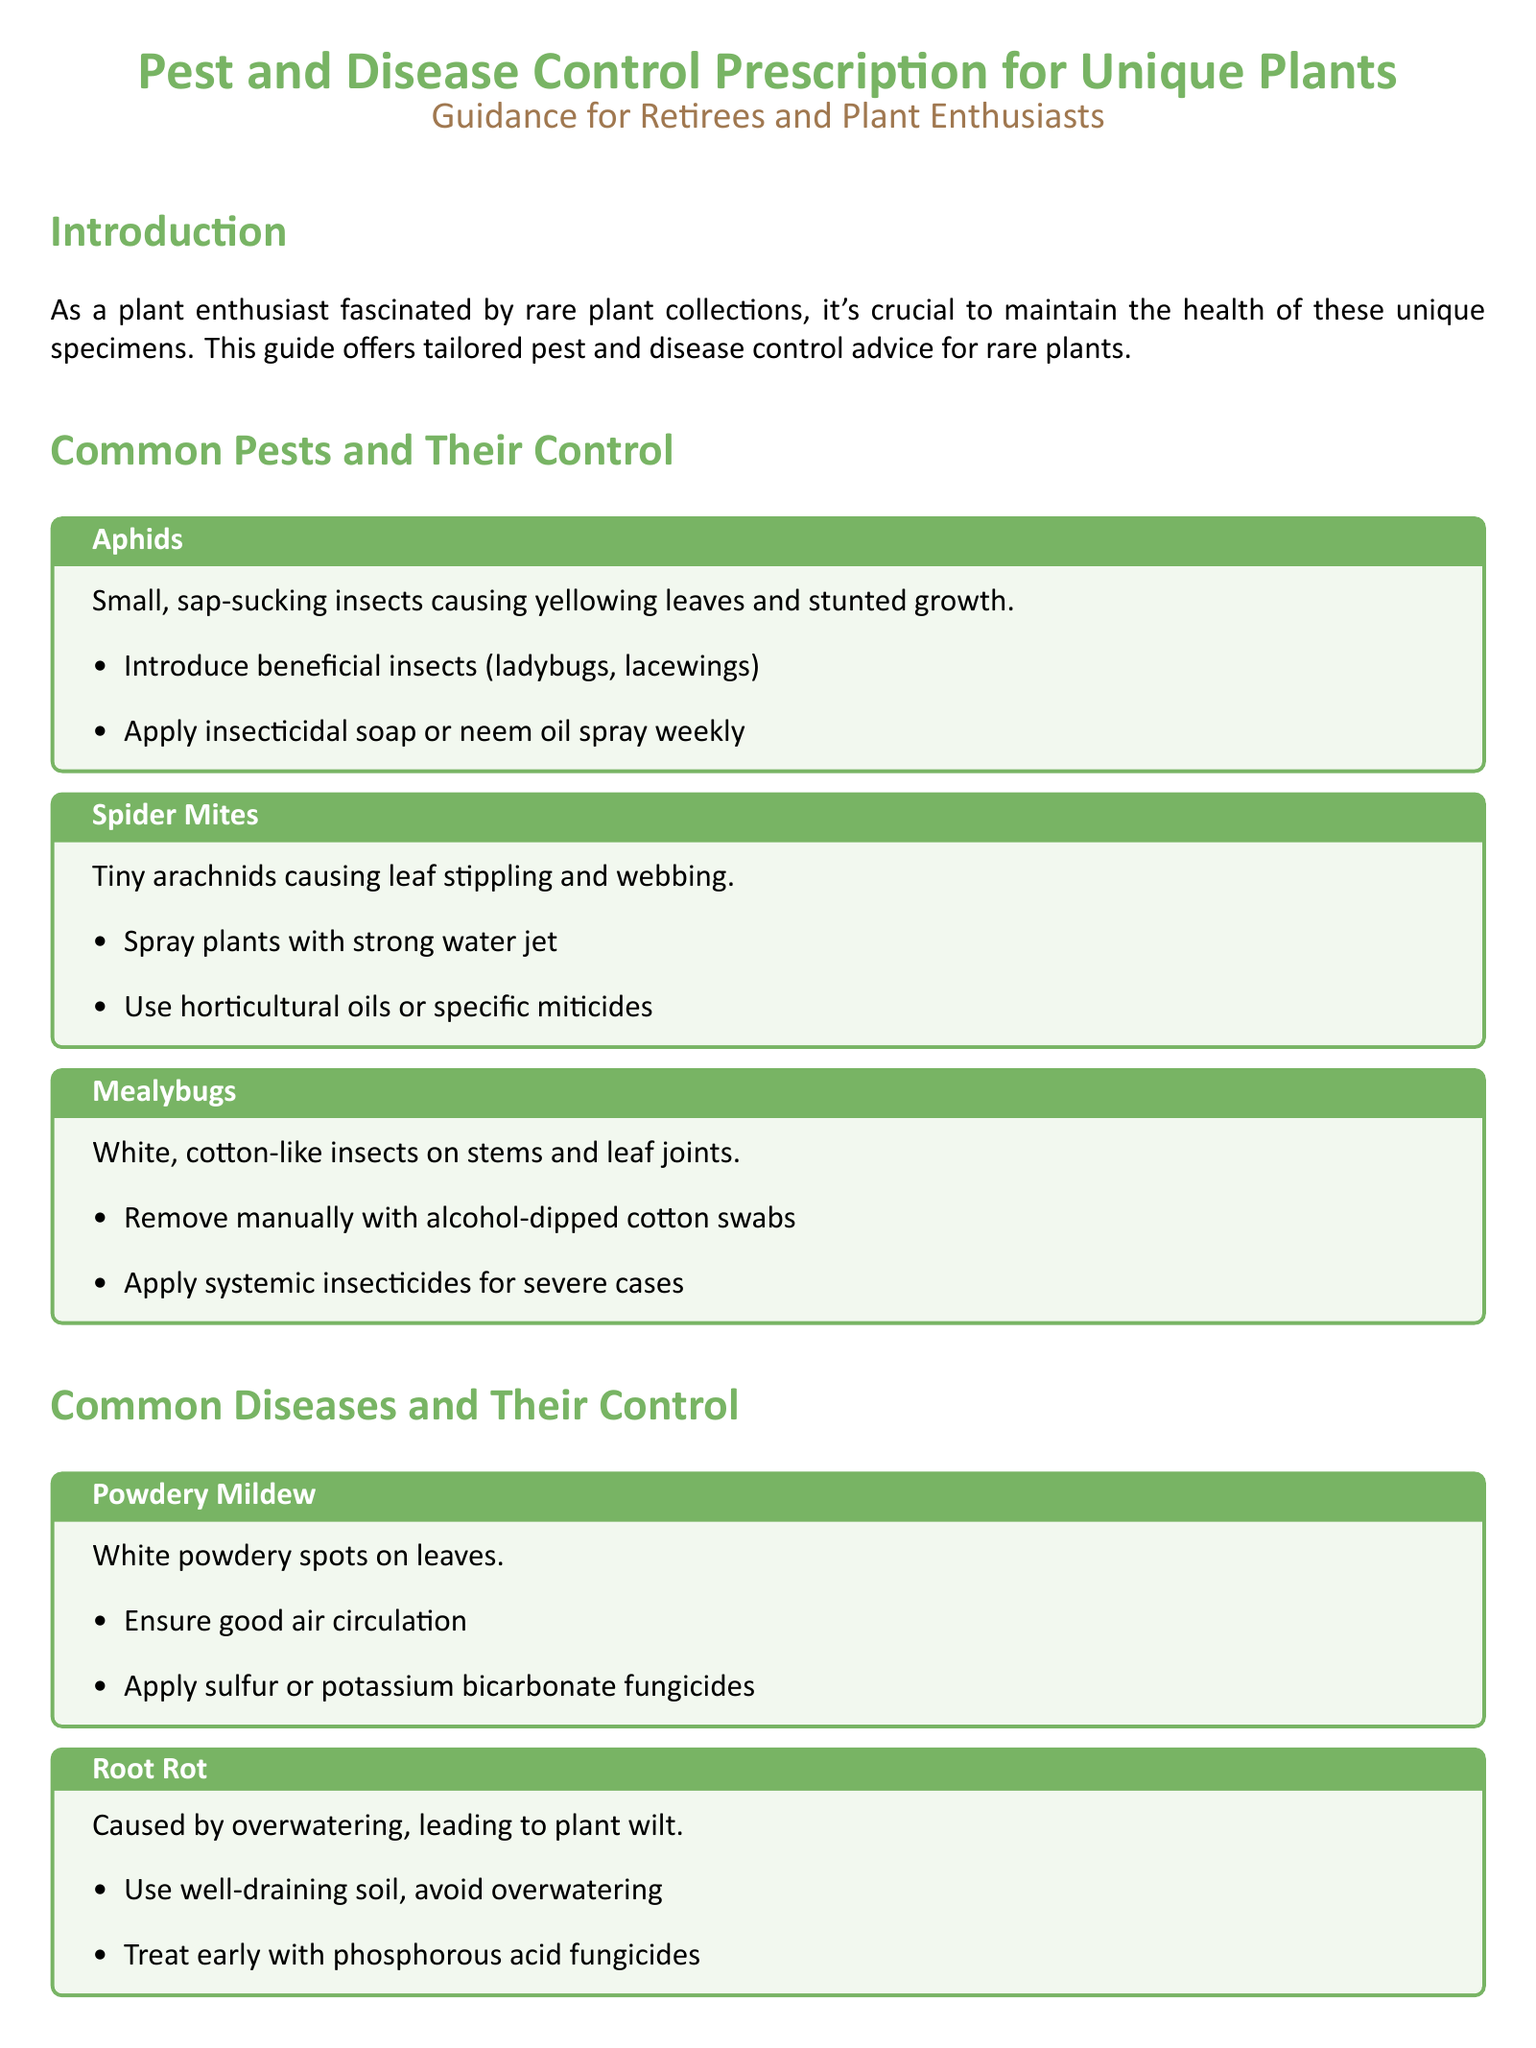what is the title of the document? The title is found prominently at the beginning of the document, summarizing its purpose.
Answer: Pest and Disease Control Prescription for Unique Plants what are two common pests mentioned? The document lists various pests in the section on common pests, highlighting two of them as examples.
Answer: Aphids, Spider Mites what treatment is recommended for powdery mildew? The section on common diseases specifies treatments for powdery mildew specifically.
Answer: Apply sulfur or potassium bicarbonate fungicides how many common diseases are listed? The document outlines specific diseases in the common disease section, which can be easily counted.
Answer: Three what is one cultural practice suggested? The conclusion mentions practices that help prevent issues in rare plants, focusing on their importance.
Answer: Quarantine New Plants what is the consequence of root rot? The section on common diseases describes root rot and its effects on plants.
Answer: Plant wilt what is a suggested method to control mealybugs? The document gives control methods for mealybugs, including a specific manual removal technique.
Answer: Remove manually with alcohol-dipped cotton swabs what is the color theme used in the document? The document uses a specific color theme that is described in the title and section headings.
Answer: Leaf green and earth brown 